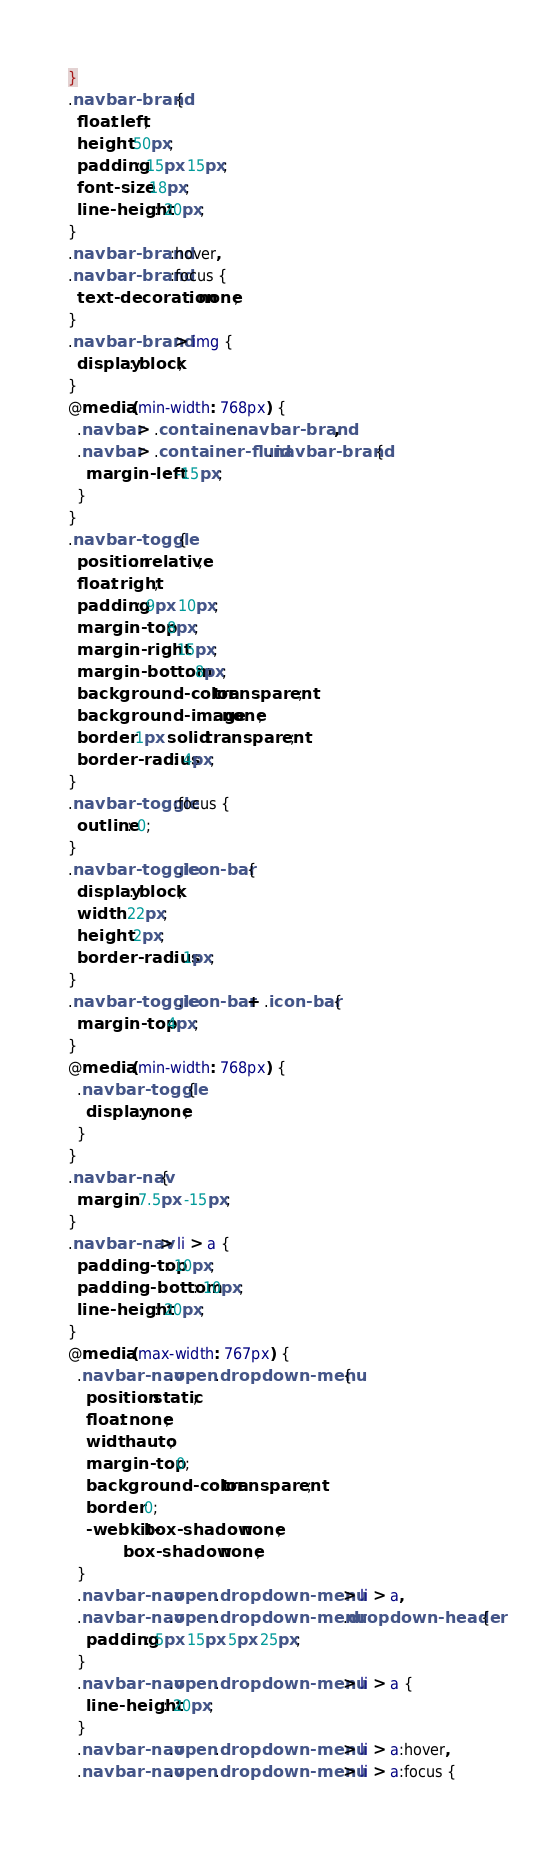Convert code to text. <code><loc_0><loc_0><loc_500><loc_500><_CSS_>}
.navbar-brand {
  float: left;
  height: 50px;
  padding: 15px 15px;
  font-size: 18px;
  line-height: 20px;
}
.navbar-brand:hover,
.navbar-brand:focus {
  text-decoration: none;
}
.navbar-brand > img {
  display: block;
}
@media (min-width: 768px) {
  .navbar > .container .navbar-brand,
  .navbar > .container-fluid .navbar-brand {
    margin-left: -15px;
  }
}
.navbar-toggle {
  position: relative;
  float: right;
  padding: 9px 10px;
  margin-top: 8px;
  margin-right: 15px;
  margin-bottom: 8px;
  background-color: transparent;
  background-image: none;
  border: 1px solid transparent;
  border-radius: 4px;
}
.navbar-toggle:focus {
  outline: 0;
}
.navbar-toggle .icon-bar {
  display: block;
  width: 22px;
  height: 2px;
  border-radius: 1px;
}
.navbar-toggle .icon-bar + .icon-bar {
  margin-top: 4px;
}
@media (min-width: 768px) {
  .navbar-toggle {
    display: none;
  }
}
.navbar-nav {
  margin: 7.5px -15px;
}
.navbar-nav > li > a {
  padding-top: 10px;
  padding-bottom: 10px;
  line-height: 20px;
}
@media (max-width: 767px) {
  .navbar-nav .open .dropdown-menu {
    position: static;
    float: none;
    width: auto;
    margin-top: 0;
    background-color: transparent;
    border: 0;
    -webkit-box-shadow: none;
            box-shadow: none;
  }
  .navbar-nav .open .dropdown-menu > li > a,
  .navbar-nav .open .dropdown-menu .dropdown-header {
    padding: 5px 15px 5px 25px;
  }
  .navbar-nav .open .dropdown-menu > li > a {
    line-height: 20px;
  }
  .navbar-nav .open .dropdown-menu > li > a:hover,
  .navbar-nav .open .dropdown-menu > li > a:focus {</code> 